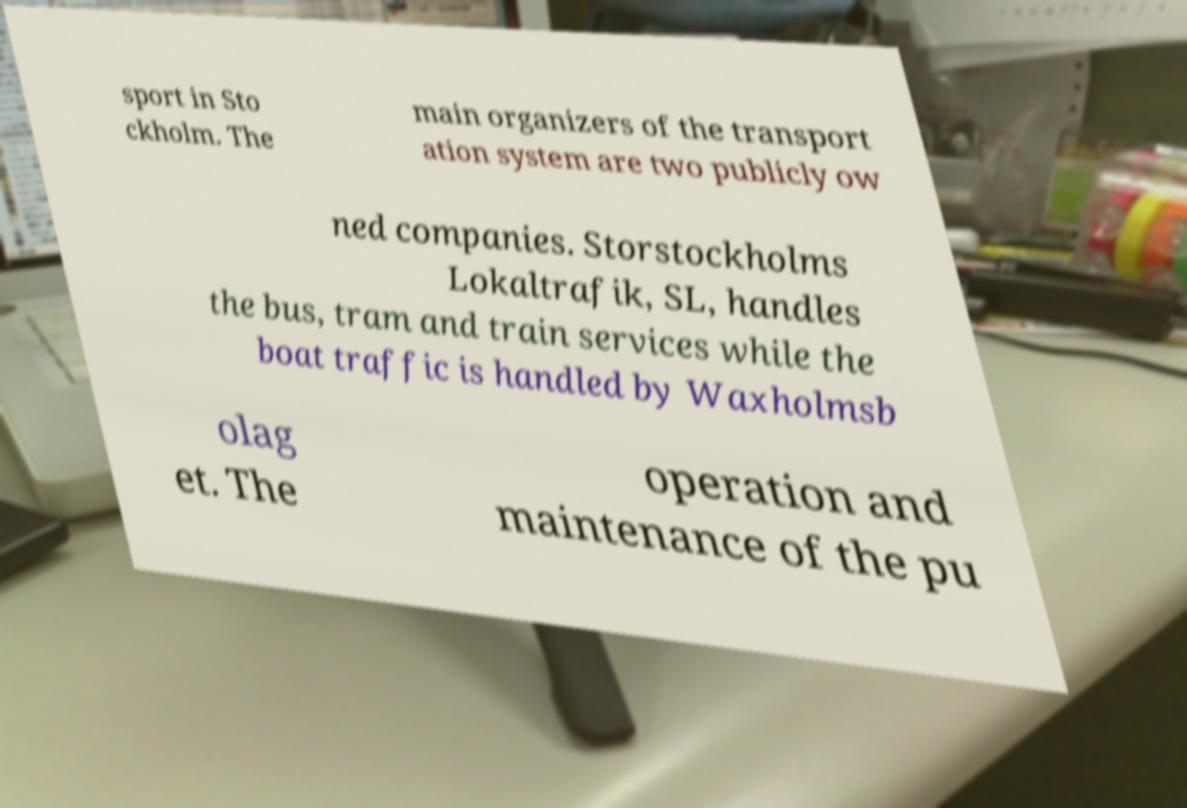I need the written content from this picture converted into text. Can you do that? sport in Sto ckholm. The main organizers of the transport ation system are two publicly ow ned companies. Storstockholms Lokaltrafik, SL, handles the bus, tram and train services while the boat traffic is handled by Waxholmsb olag et. The operation and maintenance of the pu 